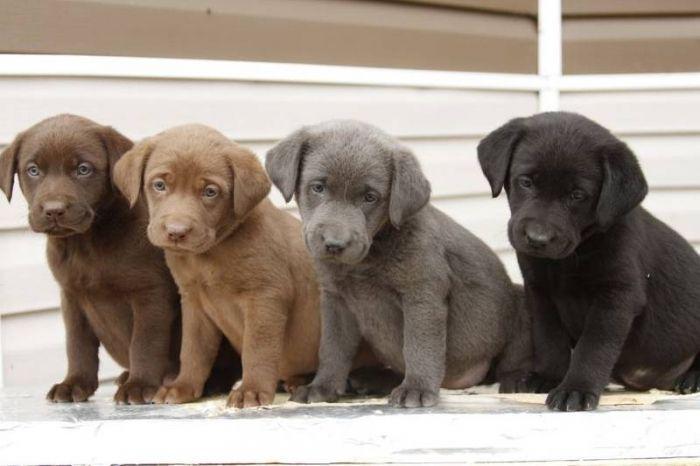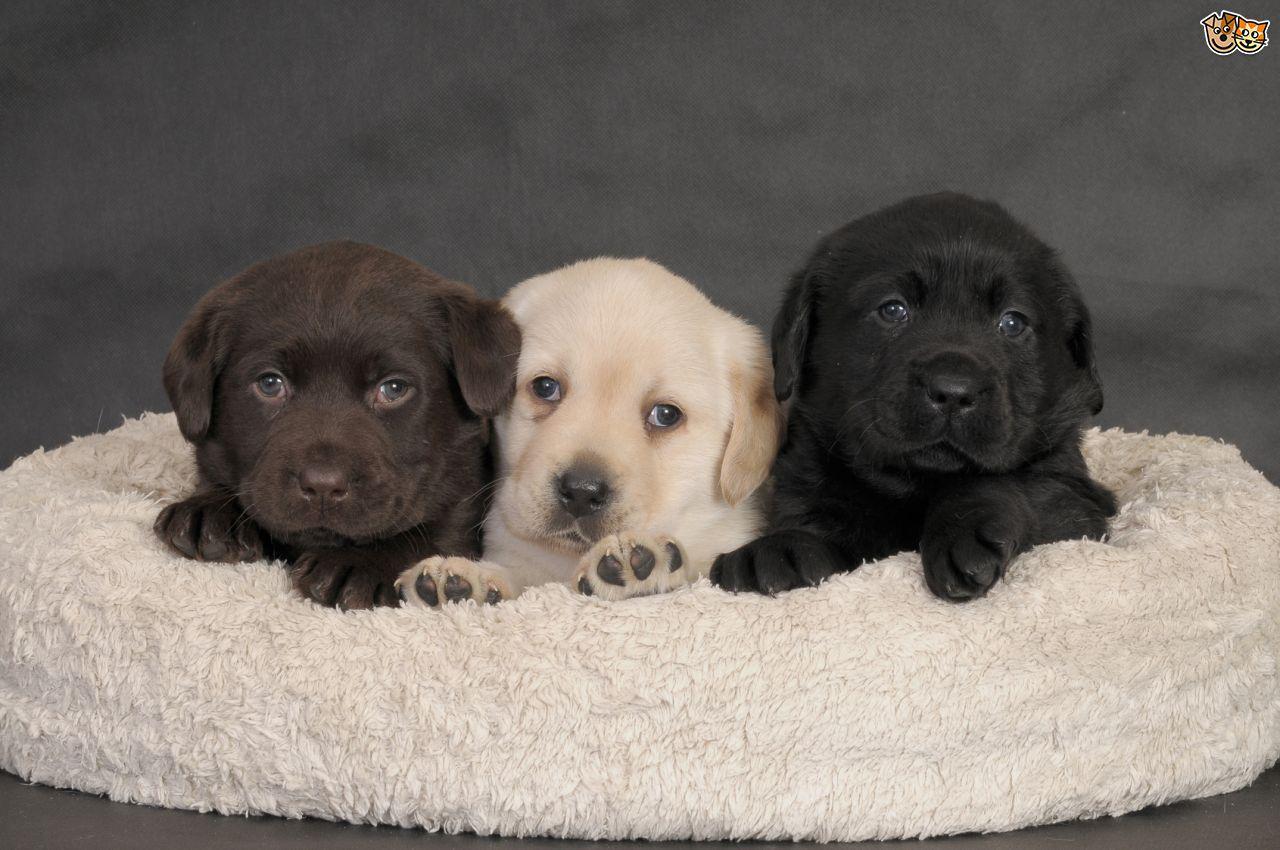The first image is the image on the left, the second image is the image on the right. Considering the images on both sides, is "An image shows three upright, non-reclining dogs posed with the black dog on the far left and the brown dog on the far right." valid? Answer yes or no. No. The first image is the image on the left, the second image is the image on the right. For the images shown, is this caption "6 dogs exactly can be seen." true? Answer yes or no. No. 